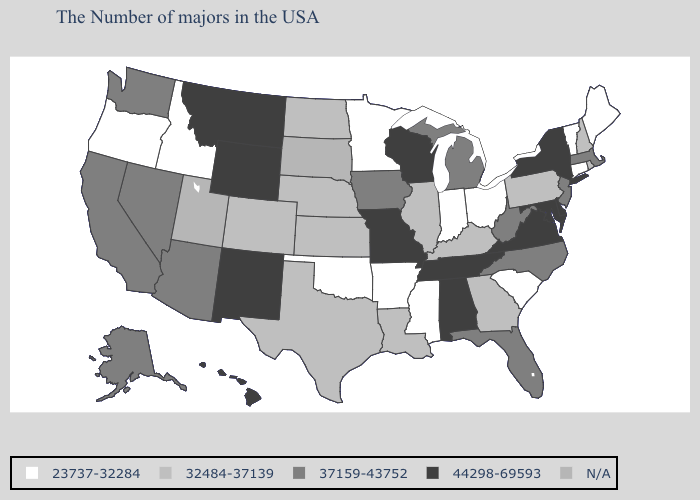Name the states that have a value in the range N/A?
Write a very short answer. South Dakota, Utah. What is the highest value in the Northeast ?
Concise answer only. 44298-69593. Which states have the lowest value in the USA?
Keep it brief. Maine, Vermont, Connecticut, South Carolina, Ohio, Indiana, Mississippi, Arkansas, Minnesota, Oklahoma, Idaho, Oregon. What is the value of Louisiana?
Write a very short answer. 32484-37139. What is the highest value in the MidWest ?
Concise answer only. 44298-69593. Name the states that have a value in the range N/A?
Quick response, please. South Dakota, Utah. What is the value of Alabama?
Write a very short answer. 44298-69593. Which states have the highest value in the USA?
Concise answer only. New York, Delaware, Maryland, Virginia, Alabama, Tennessee, Wisconsin, Missouri, Wyoming, New Mexico, Montana, Hawaii. Which states have the highest value in the USA?
Write a very short answer. New York, Delaware, Maryland, Virginia, Alabama, Tennessee, Wisconsin, Missouri, Wyoming, New Mexico, Montana, Hawaii. What is the value of Rhode Island?
Keep it brief. 32484-37139. What is the value of Tennessee?
Write a very short answer. 44298-69593. What is the value of New York?
Give a very brief answer. 44298-69593. Name the states that have a value in the range 32484-37139?
Quick response, please. Rhode Island, New Hampshire, Pennsylvania, Georgia, Kentucky, Illinois, Louisiana, Kansas, Nebraska, Texas, North Dakota, Colorado. Name the states that have a value in the range 23737-32284?
Answer briefly. Maine, Vermont, Connecticut, South Carolina, Ohio, Indiana, Mississippi, Arkansas, Minnesota, Oklahoma, Idaho, Oregon. 